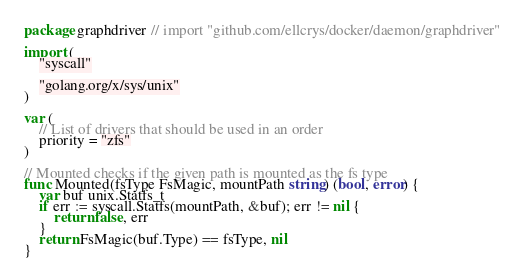<code> <loc_0><loc_0><loc_500><loc_500><_Go_>package graphdriver // import "github.com/ellcrys/docker/daemon/graphdriver"

import (
	"syscall"

	"golang.org/x/sys/unix"
)

var (
	// List of drivers that should be used in an order
	priority = "zfs"
)

// Mounted checks if the given path is mounted as the fs type
func Mounted(fsType FsMagic, mountPath string) (bool, error) {
	var buf unix.Statfs_t
	if err := syscall.Statfs(mountPath, &buf); err != nil {
		return false, err
	}
	return FsMagic(buf.Type) == fsType, nil
}
</code> 